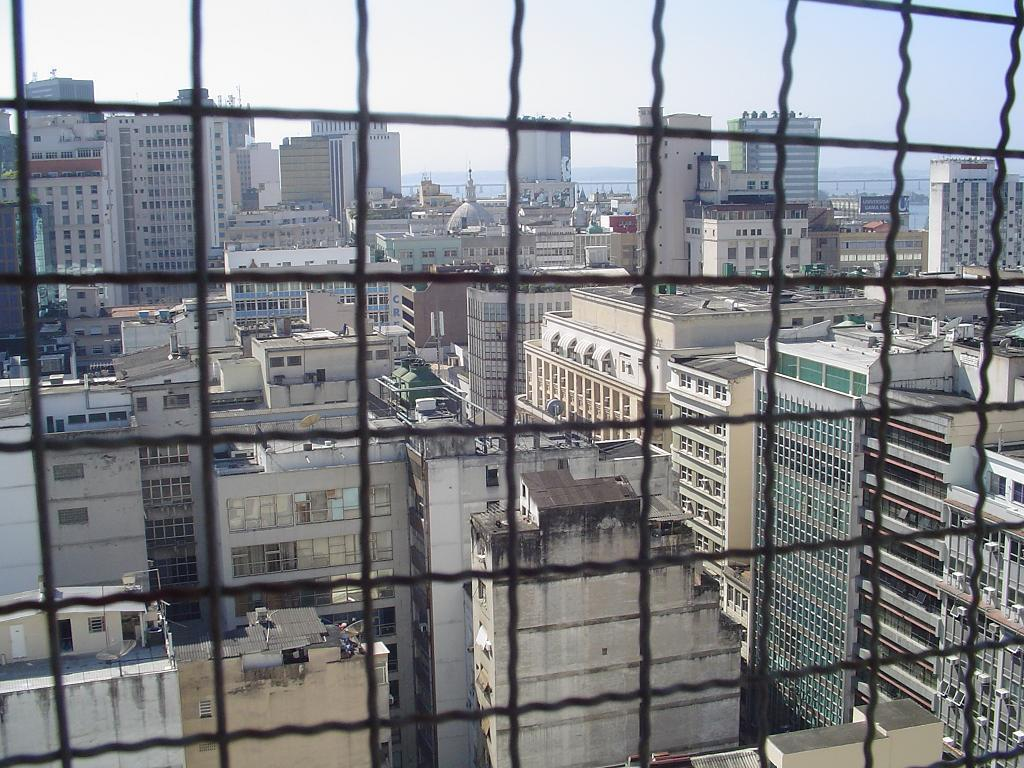What type of railing is present in the image? There is steel railing in the image. What can be seen in the background of the image? Tower buildings and the sky are visible in the background of the image. How many women are sitting on the board in the image? There is no board or women present in the image. 